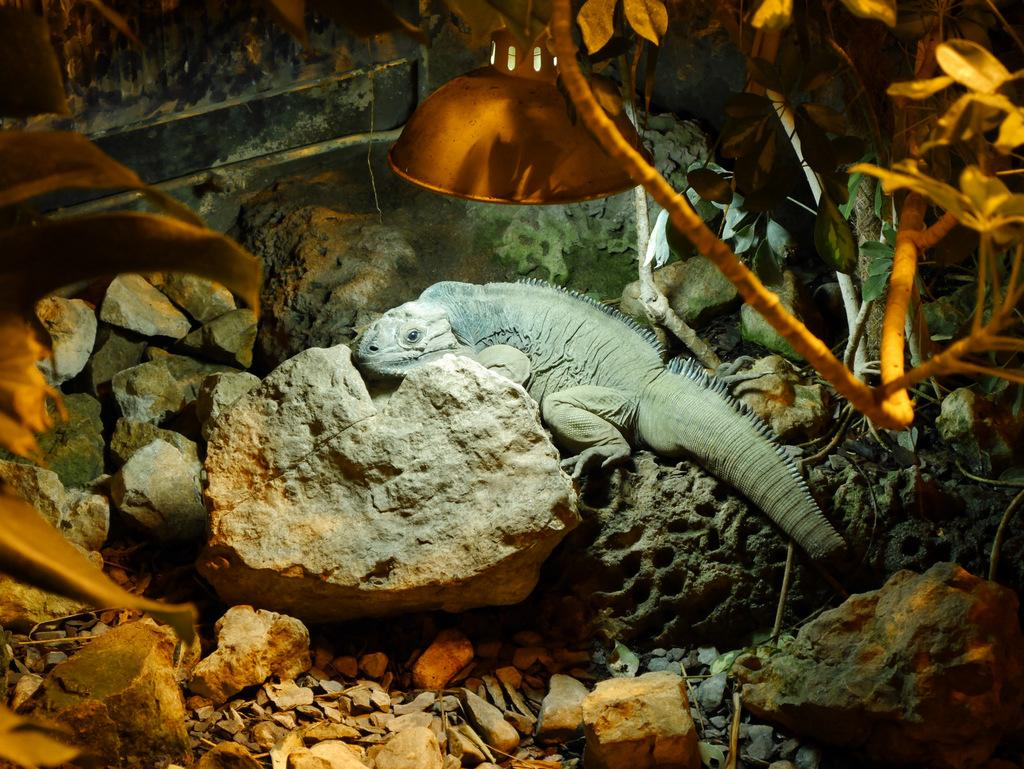What is the main subject of the image? There is an animal on a rock in the image. What other objects can be seen in the image? There is a hanging lamp in the image. What type of vegetation is present in the image? There are planted trees in the image. Can you tell me how many cribs are visible in the image? There are no cribs present in the image. What level of experience is required to begin using the hanging lamp in the image? The image does not provide information about the level of experience required to use the hanging lamp. 